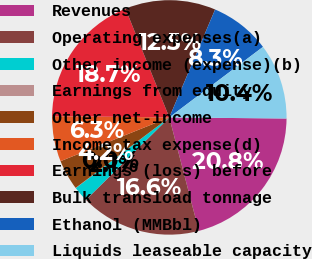Convert chart to OTSL. <chart><loc_0><loc_0><loc_500><loc_500><pie_chart><fcel>Revenues<fcel>Operating expenses(a)<fcel>Other income (expense)(b)<fcel>Earnings from equity<fcel>Other net-income<fcel>Income tax expense(d)<fcel>Earnings (loss) before<fcel>Bulk transload tonnage<fcel>Ethanol (MMBbl)<fcel>Liquids leaseable capacity<nl><fcel>20.8%<fcel>16.65%<fcel>2.11%<fcel>0.03%<fcel>4.18%<fcel>6.26%<fcel>18.73%<fcel>12.49%<fcel>8.34%<fcel>10.42%<nl></chart> 